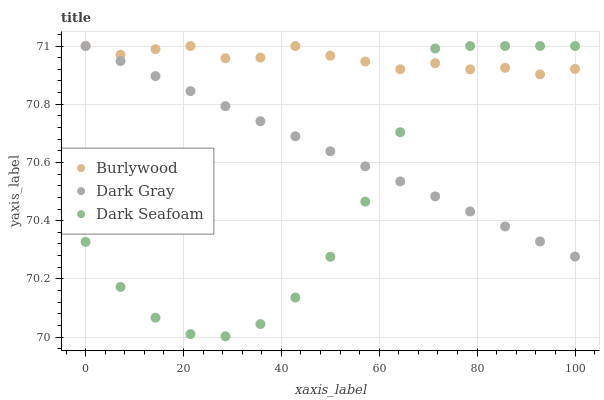Does Dark Seafoam have the minimum area under the curve?
Answer yes or no. Yes. Does Burlywood have the maximum area under the curve?
Answer yes or no. Yes. Does Dark Gray have the minimum area under the curve?
Answer yes or no. No. Does Dark Gray have the maximum area under the curve?
Answer yes or no. No. Is Dark Gray the smoothest?
Answer yes or no. Yes. Is Dark Seafoam the roughest?
Answer yes or no. Yes. Is Dark Seafoam the smoothest?
Answer yes or no. No. Is Dark Gray the roughest?
Answer yes or no. No. Does Dark Seafoam have the lowest value?
Answer yes or no. Yes. Does Dark Gray have the lowest value?
Answer yes or no. No. Does Dark Seafoam have the highest value?
Answer yes or no. Yes. Does Dark Gray intersect Dark Seafoam?
Answer yes or no. Yes. Is Dark Gray less than Dark Seafoam?
Answer yes or no. No. Is Dark Gray greater than Dark Seafoam?
Answer yes or no. No. 